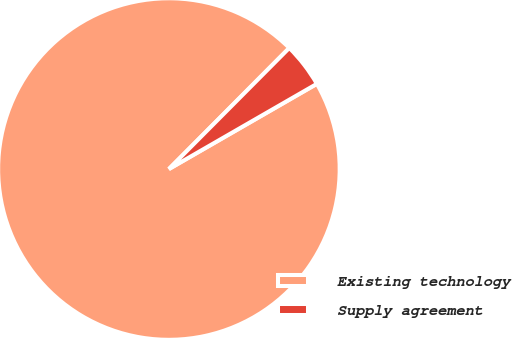<chart> <loc_0><loc_0><loc_500><loc_500><pie_chart><fcel>Existing technology<fcel>Supply agreement<nl><fcel>95.77%<fcel>4.23%<nl></chart> 